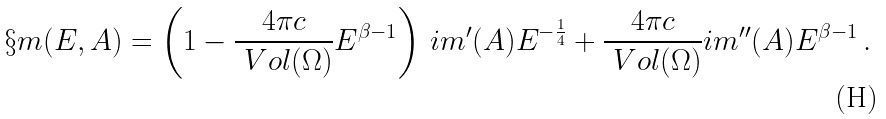<formula> <loc_0><loc_0><loc_500><loc_500>\S m ( E , A ) = \left ( 1 - \frac { 4 \pi c } { \ V o l ( \Omega ) } E ^ { \beta - 1 } \right ) \, \sl i m ^ { \prime } ( A ) E ^ { - \frac { 1 } { 4 } } + \frac { 4 \pi c } { \ V o l ( \Omega ) } \sl i m ^ { \prime \prime } ( A ) E ^ { \beta - 1 } \, .</formula> 